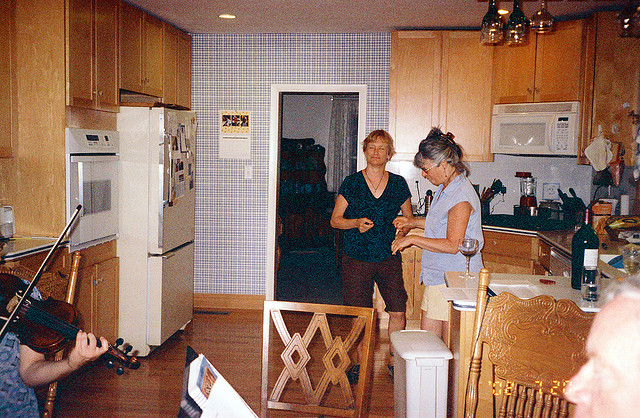Can you describe the setting of this photo? Certainly! The photo captures a warm and casual domestic scene in a home kitchen, where a small gathering seems to be taking place. One individual is playing the violin, adding a musical ambience, while two others engage in a conversation by the central island. The presence of wine bottles suggests they might be enjoying a social event or a family gathering. 